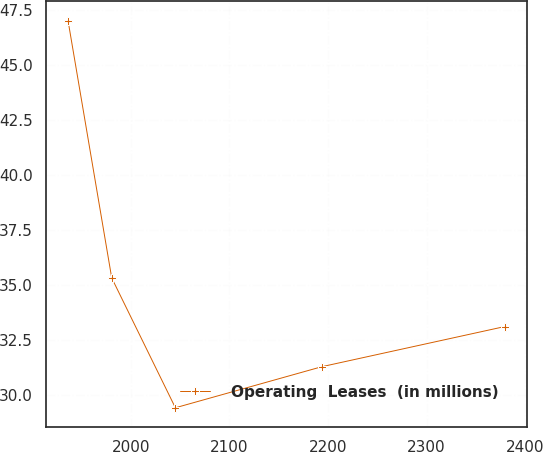Convert chart. <chart><loc_0><loc_0><loc_500><loc_500><line_chart><ecel><fcel>Operating  Leases  (in millions)<nl><fcel>1936.35<fcel>47.01<nl><fcel>1980.64<fcel>35.32<nl><fcel>2045.2<fcel>29.42<nl><fcel>2194.05<fcel>31.29<nl><fcel>2379.21<fcel>33.11<nl></chart> 